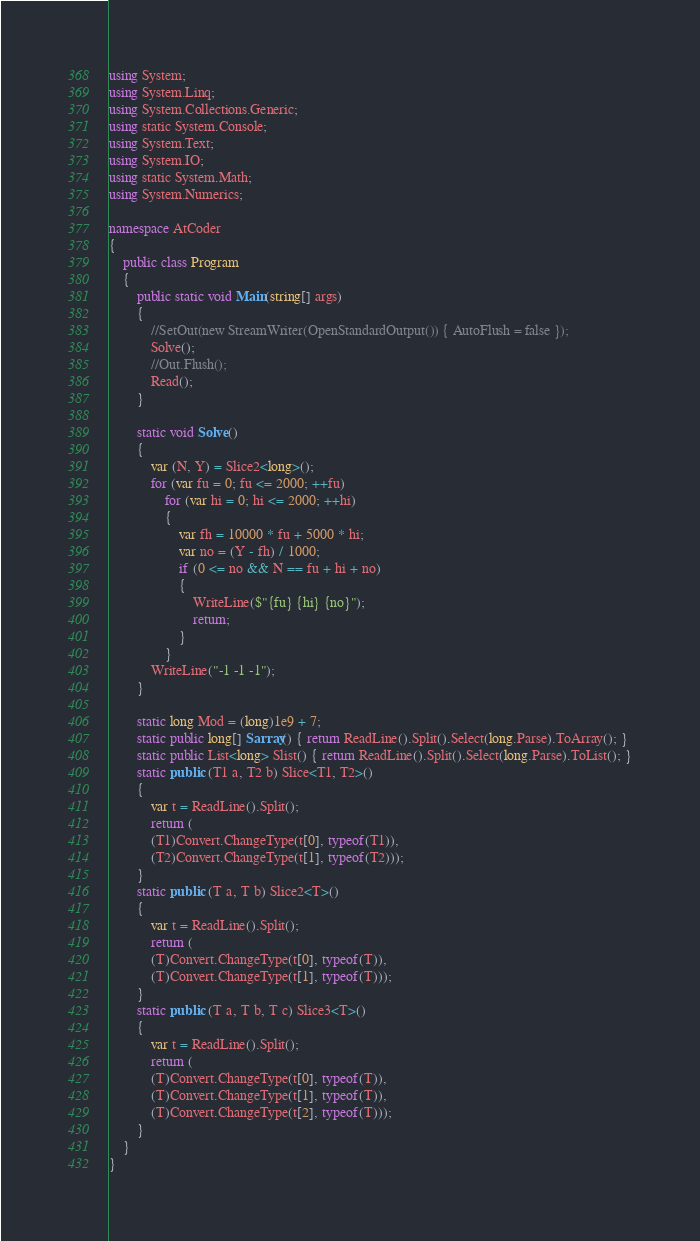Convert code to text. <code><loc_0><loc_0><loc_500><loc_500><_C#_>using System;
using System.Linq;
using System.Collections.Generic;
using static System.Console;
using System.Text;
using System.IO;
using static System.Math;
using System.Numerics;

namespace AtCoder
{
    public class Program
    {
        public static void Main(string[] args)
        {
            //SetOut(new StreamWriter(OpenStandardOutput()) { AutoFlush = false });
            Solve();
            //Out.Flush();
            Read();
        }

        static void Solve()
        {
            var (N, Y) = Slice2<long>();
            for (var fu = 0; fu <= 2000; ++fu)
                for (var hi = 0; hi <= 2000; ++hi)
                {
                    var fh = 10000 * fu + 5000 * hi;
                    var no = (Y - fh) / 1000;
                    if (0 <= no && N == fu + hi + no)
                    {
                        WriteLine($"{fu} {hi} {no}");
                        return;
                    }
                }
            WriteLine("-1 -1 -1");
        }

        static long Mod = (long)1e9 + 7;
        static public long[] Sarray() { return ReadLine().Split().Select(long.Parse).ToArray(); }
        static public List<long> Slist() { return ReadLine().Split().Select(long.Parse).ToList(); }
        static public (T1 a, T2 b) Slice<T1, T2>()
        {
            var t = ReadLine().Split();
            return (
            (T1)Convert.ChangeType(t[0], typeof(T1)),
            (T2)Convert.ChangeType(t[1], typeof(T2)));
        }
        static public (T a, T b) Slice2<T>()
        {
            var t = ReadLine().Split();
            return (
            (T)Convert.ChangeType(t[0], typeof(T)),
            (T)Convert.ChangeType(t[1], typeof(T)));
        }
        static public (T a, T b, T c) Slice3<T>()
        {
            var t = ReadLine().Split();
            return (
            (T)Convert.ChangeType(t[0], typeof(T)),
            (T)Convert.ChangeType(t[1], typeof(T)),
            (T)Convert.ChangeType(t[2], typeof(T)));
        }
    }
}</code> 